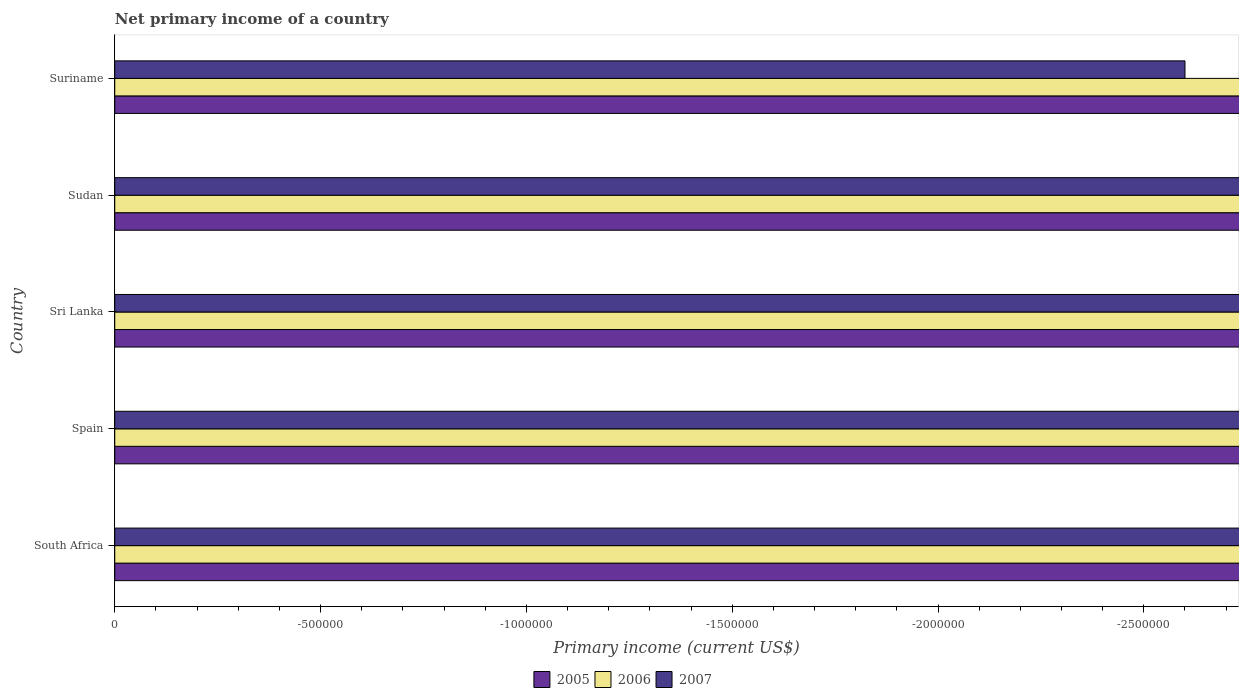How many different coloured bars are there?
Provide a short and direct response. 0. Are the number of bars per tick equal to the number of legend labels?
Your answer should be compact. No. Are the number of bars on each tick of the Y-axis equal?
Ensure brevity in your answer.  Yes. How many bars are there on the 1st tick from the bottom?
Offer a very short reply. 0. What is the label of the 5th group of bars from the top?
Make the answer very short. South Africa. In how many cases, is the number of bars for a given country not equal to the number of legend labels?
Provide a short and direct response. 5. Across all countries, what is the minimum primary income in 2007?
Provide a short and direct response. 0. What is the difference between the primary income in 2007 in Spain and the primary income in 2006 in Sudan?
Your answer should be very brief. 0. What is the average primary income in 2006 per country?
Keep it short and to the point. 0. In how many countries, is the primary income in 2005 greater than -1300000 US$?
Offer a terse response. 0. In how many countries, is the primary income in 2007 greater than the average primary income in 2007 taken over all countries?
Your response must be concise. 0. How many bars are there?
Provide a succinct answer. 0. What is the difference between two consecutive major ticks on the X-axis?
Keep it short and to the point. 5.00e+05. Does the graph contain grids?
Offer a very short reply. No. What is the title of the graph?
Provide a short and direct response. Net primary income of a country. What is the label or title of the X-axis?
Ensure brevity in your answer.  Primary income (current US$). What is the label or title of the Y-axis?
Provide a short and direct response. Country. What is the Primary income (current US$) in 2006 in Spain?
Make the answer very short. 0. What is the Primary income (current US$) in 2005 in Sri Lanka?
Provide a succinct answer. 0. What is the Primary income (current US$) of 2006 in Sri Lanka?
Keep it short and to the point. 0. What is the Primary income (current US$) of 2005 in Sudan?
Provide a succinct answer. 0. What is the Primary income (current US$) of 2006 in Sudan?
Your answer should be compact. 0. What is the Primary income (current US$) of 2005 in Suriname?
Your answer should be very brief. 0. What is the Primary income (current US$) of 2006 in Suriname?
Your response must be concise. 0. What is the average Primary income (current US$) of 2006 per country?
Provide a succinct answer. 0. What is the average Primary income (current US$) in 2007 per country?
Your answer should be very brief. 0. 